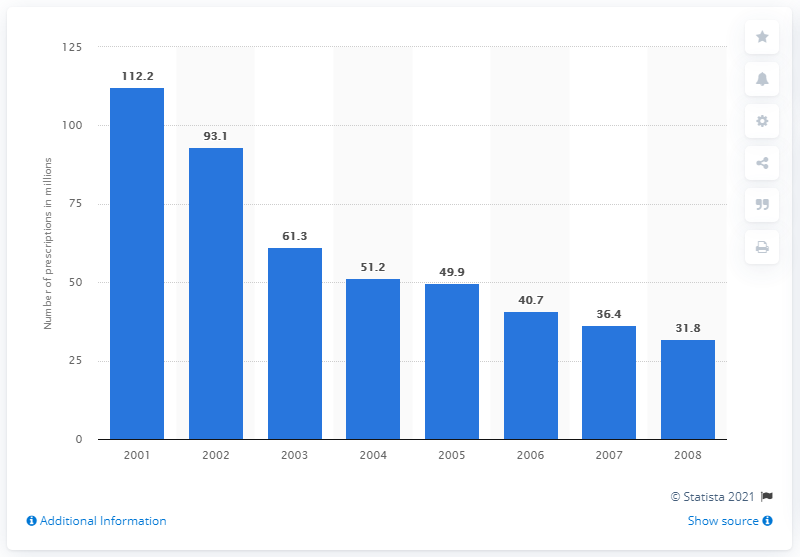Highlight a few significant elements in this photo. There were 31.8 prescriptions in the United States in 2008. 